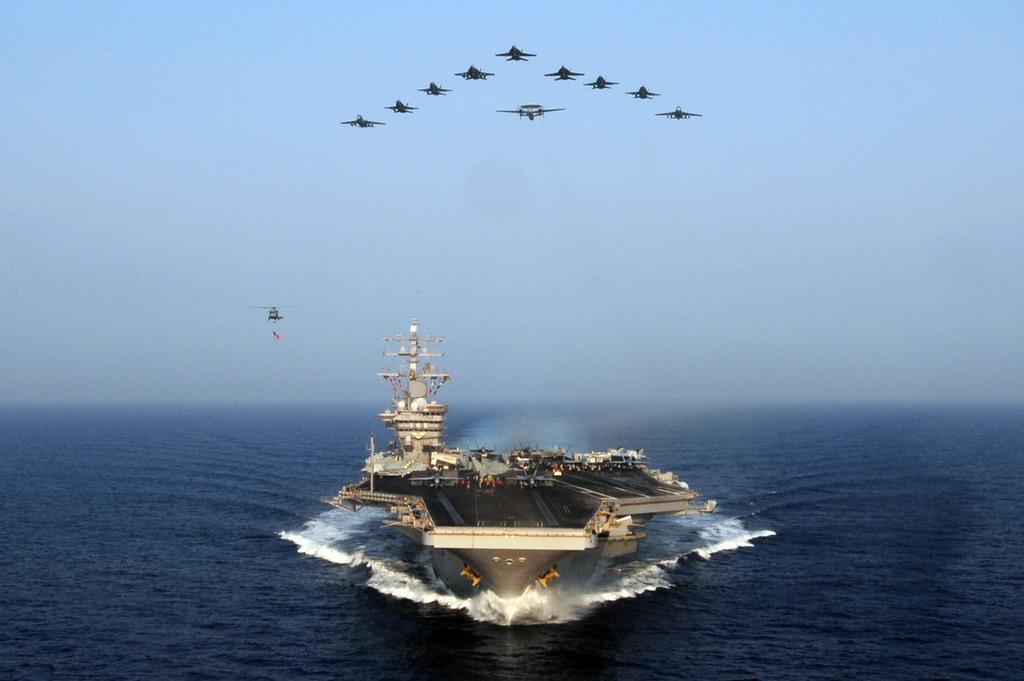Please provide a concise description of this image. This picture consists of ship visible on the ocean ,at the top I can see flights and the sky visible at the top. 